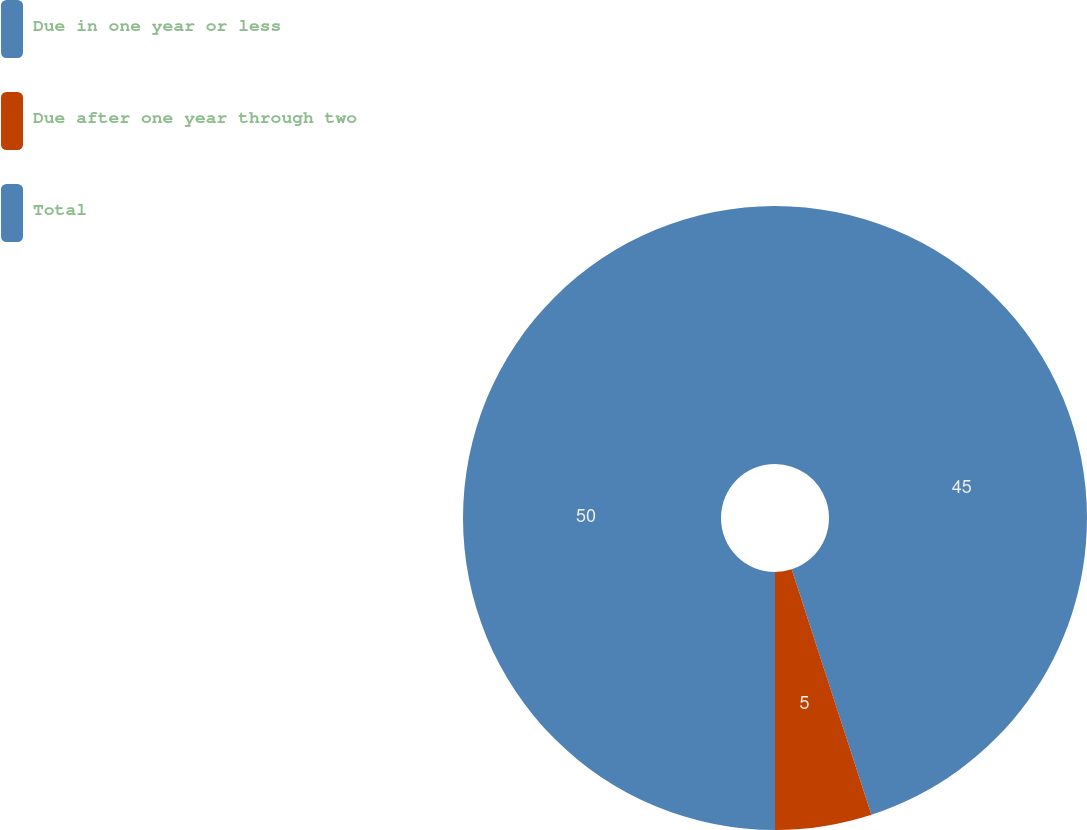Convert chart. <chart><loc_0><loc_0><loc_500><loc_500><pie_chart><fcel>Due in one year or less<fcel>Due after one year through two<fcel>Total<nl><fcel>45.0%<fcel>5.0%<fcel>50.0%<nl></chart> 